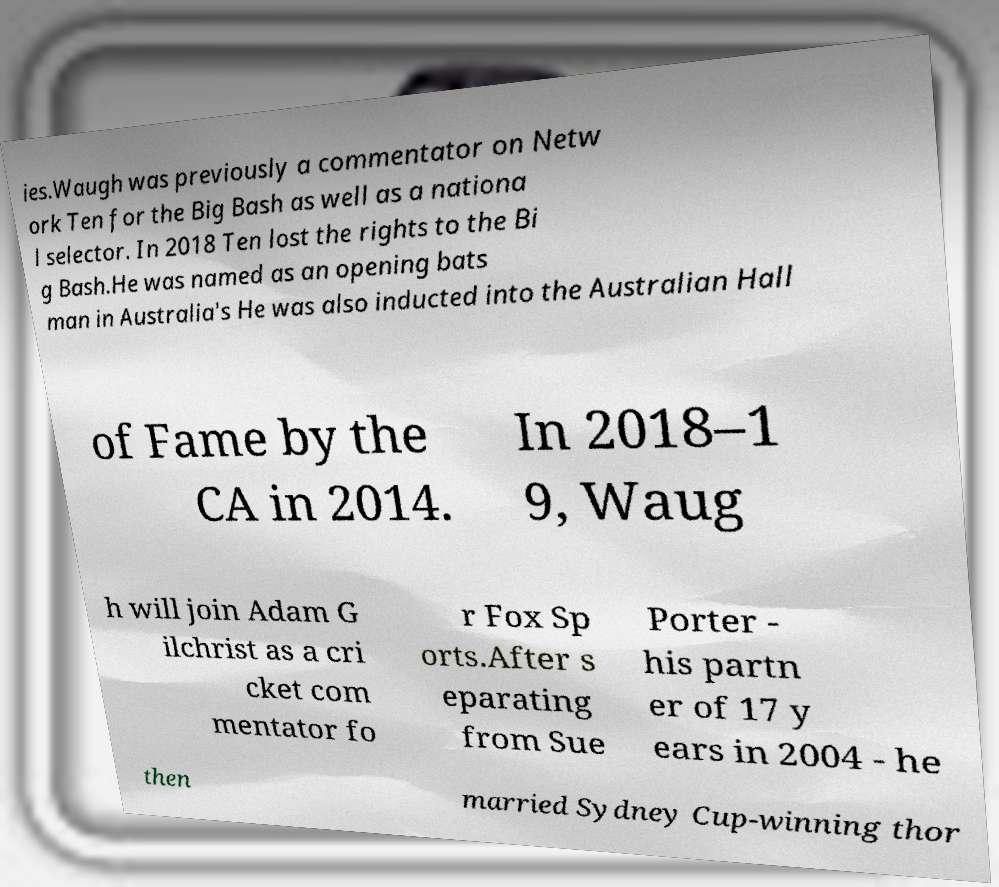I need the written content from this picture converted into text. Can you do that? ies.Waugh was previously a commentator on Netw ork Ten for the Big Bash as well as a nationa l selector. In 2018 Ten lost the rights to the Bi g Bash.He was named as an opening bats man in Australia's He was also inducted into the Australian Hall of Fame by the CA in 2014. In 2018–1 9, Waug h will join Adam G ilchrist as a cri cket com mentator fo r Fox Sp orts.After s eparating from Sue Porter - his partn er of 17 y ears in 2004 - he then married Sydney Cup-winning thor 